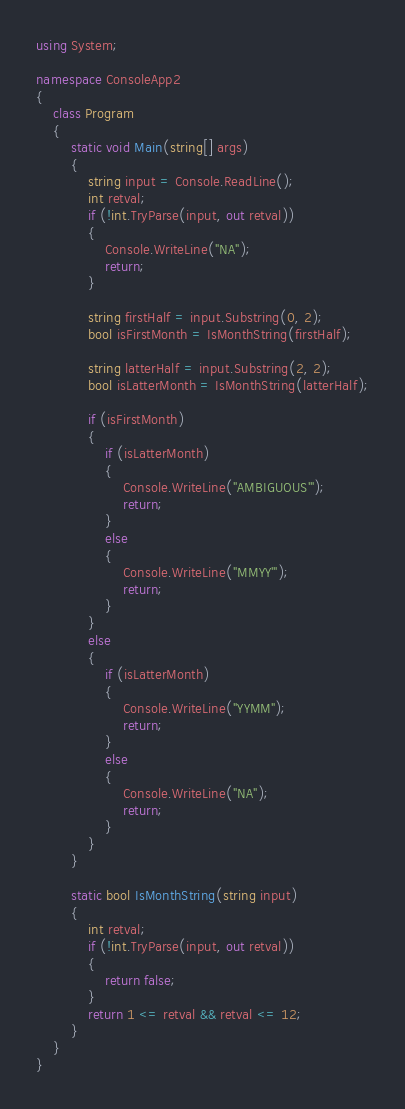Convert code to text. <code><loc_0><loc_0><loc_500><loc_500><_C#_>using System;

namespace ConsoleApp2
{
	class Program
	{
		static void Main(string[] args)
		{
			string input = Console.ReadLine();
			int retval;
			if (!int.TryParse(input, out retval))
			{
				Console.WriteLine("NA");
				return;
			}

			string firstHalf = input.Substring(0, 2);
			bool isFirstMonth = IsMonthString(firstHalf);

			string latterHalf = input.Substring(2, 2);
			bool isLatterMonth = IsMonthString(latterHalf);

			if (isFirstMonth)
			{
				if (isLatterMonth)
				{
					Console.WriteLine("AMBIGUOUS'");
					return;
				}
				else
				{
					Console.WriteLine("MMYY'");
					return;
				}
			}
			else
			{
				if (isLatterMonth)
				{
					Console.WriteLine("YYMM");
					return;
				}
				else
				{
					Console.WriteLine("NA");
					return;
				}
			}
		}

		static bool IsMonthString(string input)
		{
			int retval;
			if (!int.TryParse(input, out retval))
			{
				return false;
			}
			return 1 <= retval && retval <= 12;
		}
	}
}
</code> 